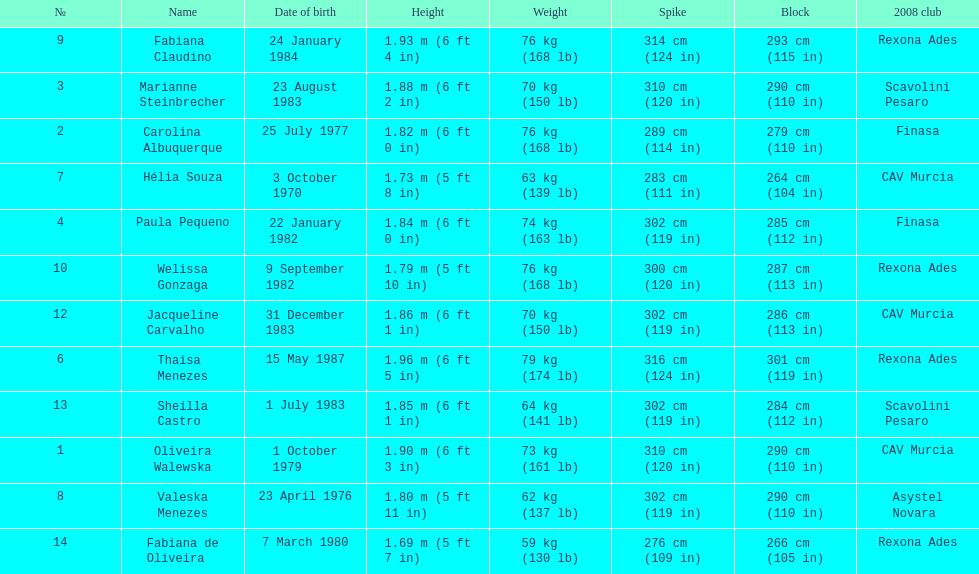Which athlete has the shortest height of just 5 feet 7 inches? Fabiana de Oliveira. 